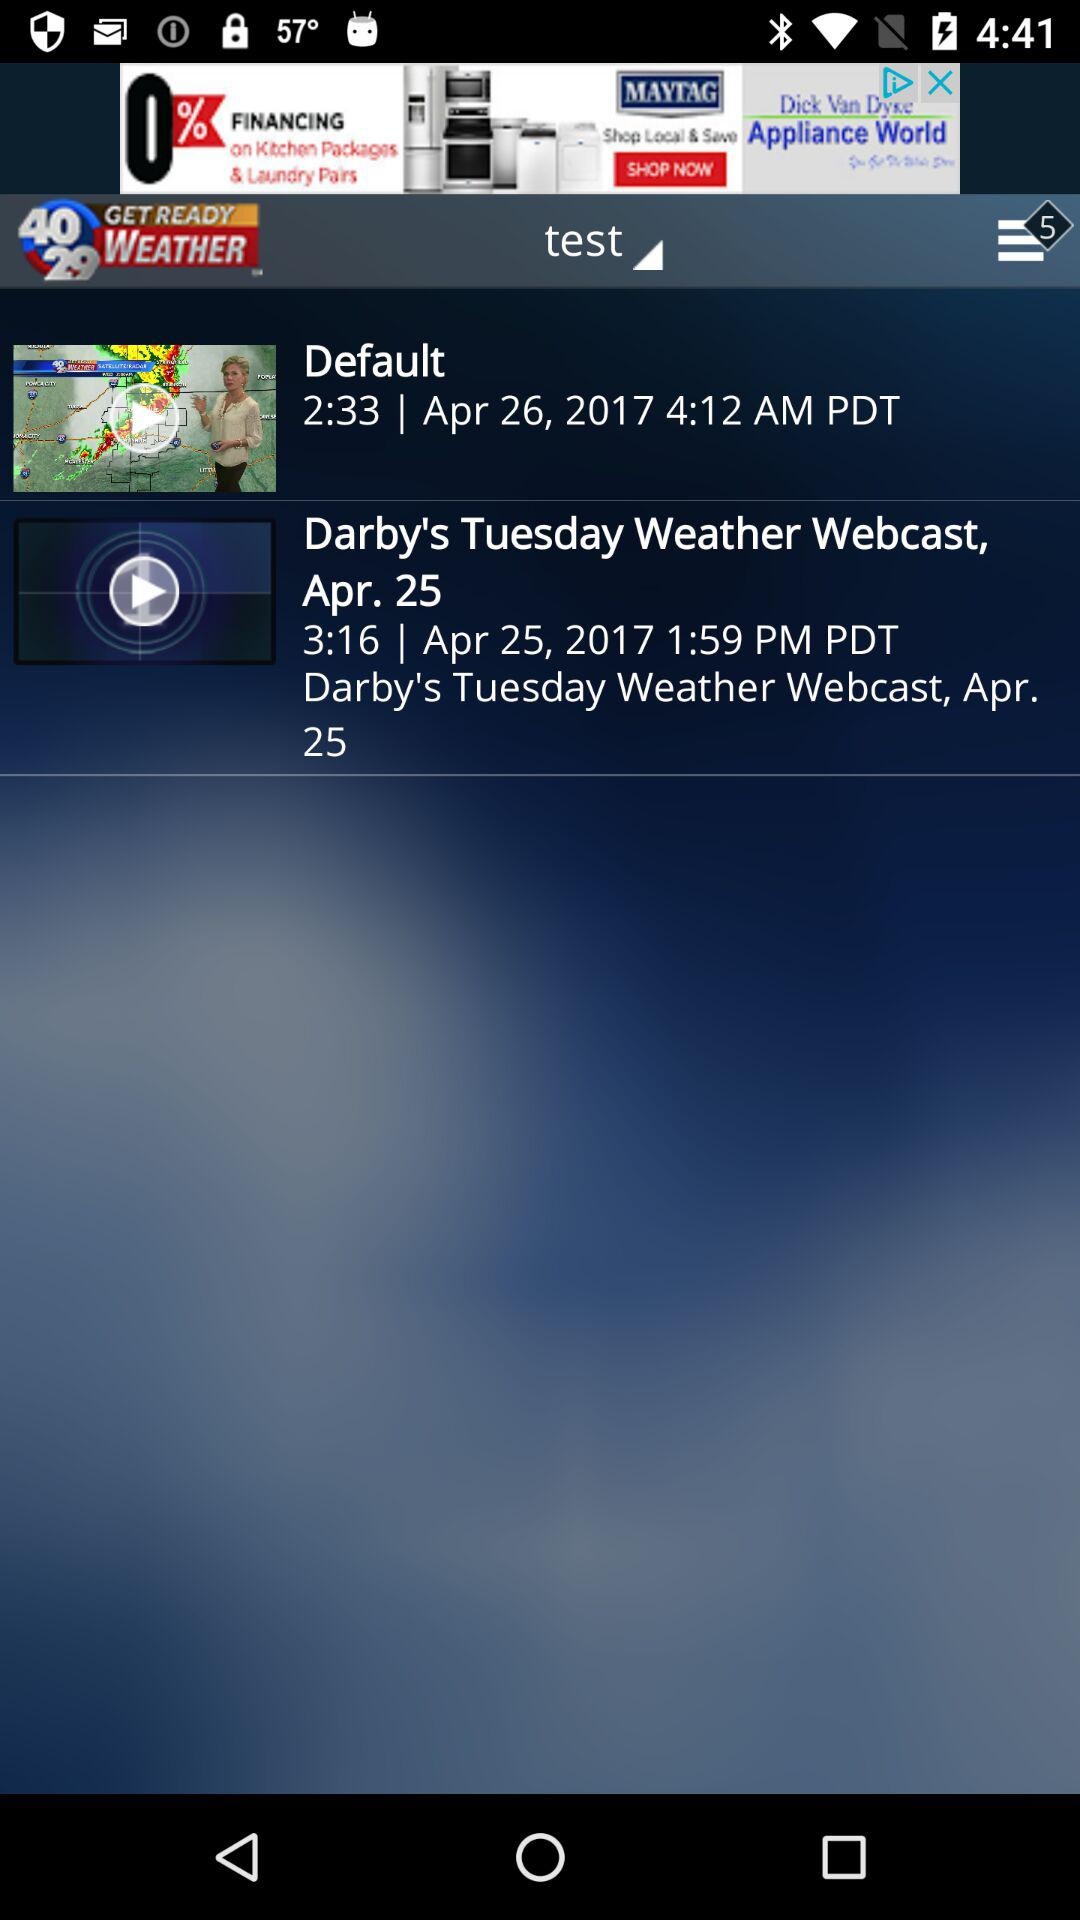How many more seconds is the length of the second video than the first video?
Answer the question using a single word or phrase. 43 